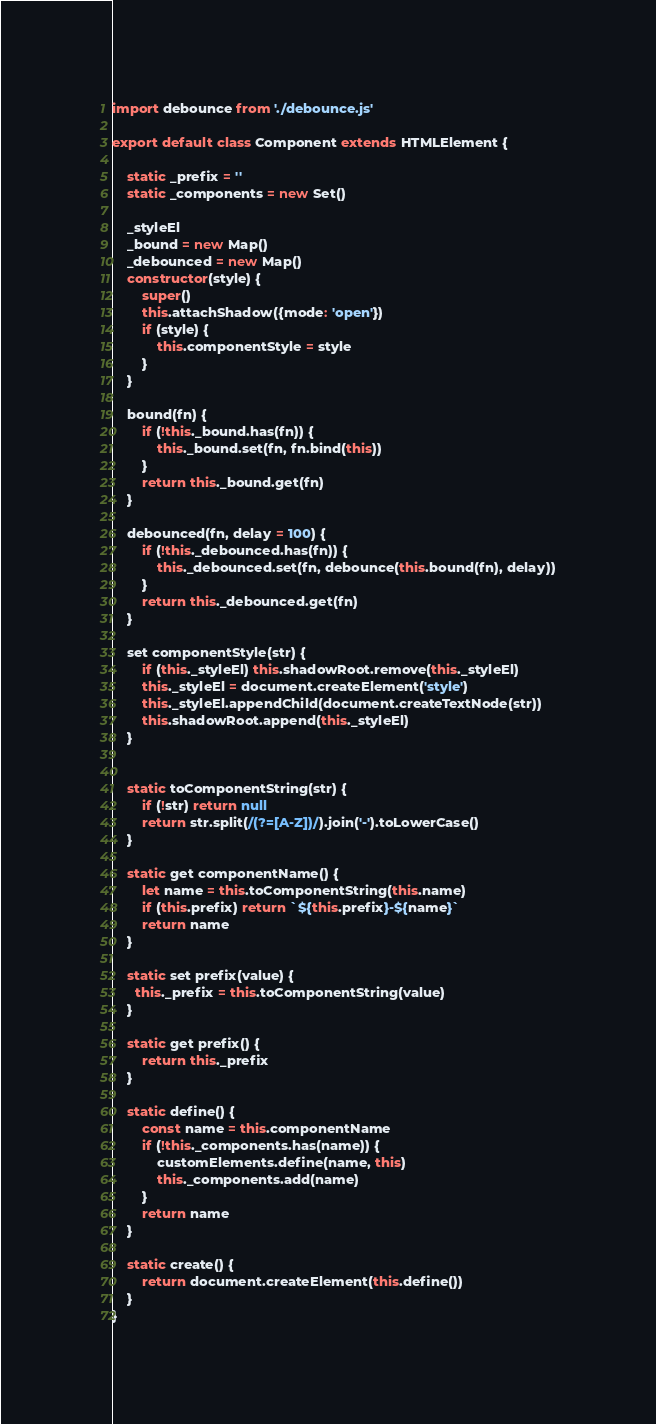<code> <loc_0><loc_0><loc_500><loc_500><_JavaScript_>import debounce from './debounce.js'

export default class Component extends HTMLElement {

    static _prefix = ''
    static _components = new Set()
    
    _styleEl
    _bound = new Map()
    _debounced = new Map()
    constructor(style) {
        super()
        this.attachShadow({mode: 'open'})
        if (style) {
            this.componentStyle = style
        }
    }

    bound(fn) {
        if (!this._bound.has(fn)) {
            this._bound.set(fn, fn.bind(this))
        }
        return this._bound.get(fn)
    }

    debounced(fn, delay = 100) {
        if (!this._debounced.has(fn)) {
            this._debounced.set(fn, debounce(this.bound(fn), delay))
        }
        return this._debounced.get(fn)
    }

    set componentStyle(str) {
        if (this._styleEl) this.shadowRoot.remove(this._styleEl)
        this._styleEl = document.createElement('style')
        this._styleEl.appendChild(document.createTextNode(str))
        this.shadowRoot.append(this._styleEl)
    }


    static toComponentString(str) {
        if (!str) return null
        return str.split(/(?=[A-Z])/).join('-').toLowerCase()
    }
    
    static get componentName() {
        let name = this.toComponentString(this.name)
        if (this.prefix) return `${this.prefix}-${name}`
        return name
    }
    
    static set prefix(value) {
      this._prefix = this.toComponentString(value)
    }
    
    static get prefix() {
        return this._prefix
    }
      
    static define() {
        const name = this.componentName
        if (!this._components.has(name)) {
            customElements.define(name, this)
            this._components.add(name)
        }
        return name
    }

    static create() {
        return document.createElement(this.define())
    }
}</code> 